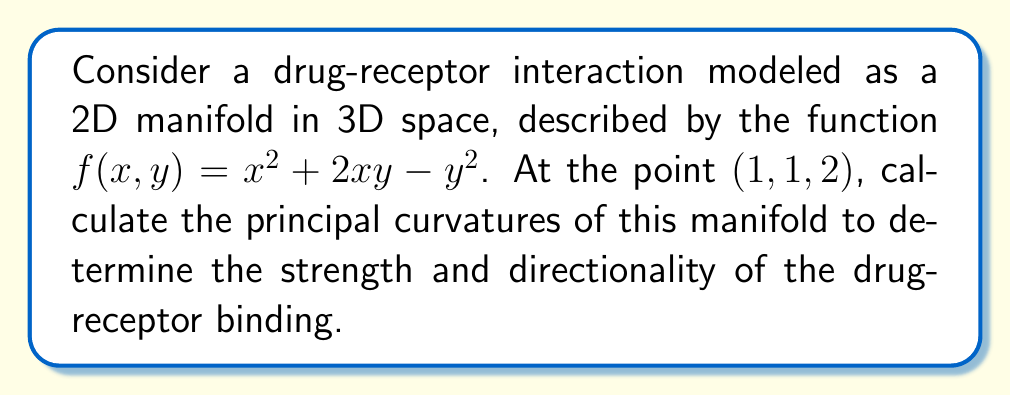What is the answer to this math problem? To find the principal curvatures, we need to follow these steps:

1) First, we need to calculate the first and second partial derivatives of $f(x,y)$:

   $f_x = 2x + 2y$
   $f_y = 2x - 2y$
   $f_{xx} = 2$
   $f_{yy} = -2$
   $f_{xy} = f_{yx} = 2$

2) At the point (1,1,2), we can calculate the normal vector:

   $\vec{N} = \frac{(-f_x, -f_y, 1)}{\sqrt{1 + f_x^2 + f_y^2}}$
   
   $= \frac{(-4, -2, 1)}{\sqrt{1 + 16 + 4}} = \frac{(-4, -2, 1)}{\sqrt{21}}$

3) Now we can form the shape operator matrix $S$:

   $S = \frac{1}{1 + f_x^2 + f_y^2} \begin{pmatrix} 
   f_{xx}(1+f_y^2) - f_xf_yf_{xy} & f_{xy}(1+f_y^2) - f_yf_{yy} \\
   f_{xy}(1+f_x^2) - f_xf_{xx} & f_{yy}(1+f_x^2) - f_xf_yf_{xy}
   \end{pmatrix}$

4) Substituting our values:

   $S = \frac{1}{21} \begin{pmatrix} 
   2(1+4) - 4 \cdot 2 \cdot 2 & 2(1+4) - 2(-2) \\
   2(1+16) - 4 \cdot 2 & -2(1+16) - 4 \cdot 2 \cdot 2
   \end{pmatrix}$

   $= \frac{1}{21} \begin{pmatrix} 
   -6 & 14 \\
   30 & -38
   \end{pmatrix}$

5) The principal curvatures are the eigenvalues of this matrix. To find them, we solve the characteristic equation:

   $det(S - \lambda I) = 0$

   $\left(\frac{-6}{21} - \lambda\right)\left(\frac{-38}{21} - \lambda\right) - \frac{14}{21} \cdot \frac{30}{21} = 0$

6) Simplifying and solving this quadratic equation:

   $\lambda^2 + 2\lambda - \frac{4}{21} = 0$

   $\lambda = \frac{-2 \pm \sqrt{4 + \frac{16}{21}}}{2} = -1 \pm \sqrt{\frac{25}{21}}$

Therefore, the principal curvatures are:

$k_1 = -1 + \sqrt{\frac{25}{21}}$ and $k_2 = -1 - \sqrt{\frac{25}{21}}$
Answer: $k_1 = -1 + \sqrt{\frac{25}{21}}$, $k_2 = -1 - \sqrt{\frac{25}{21}}$ 